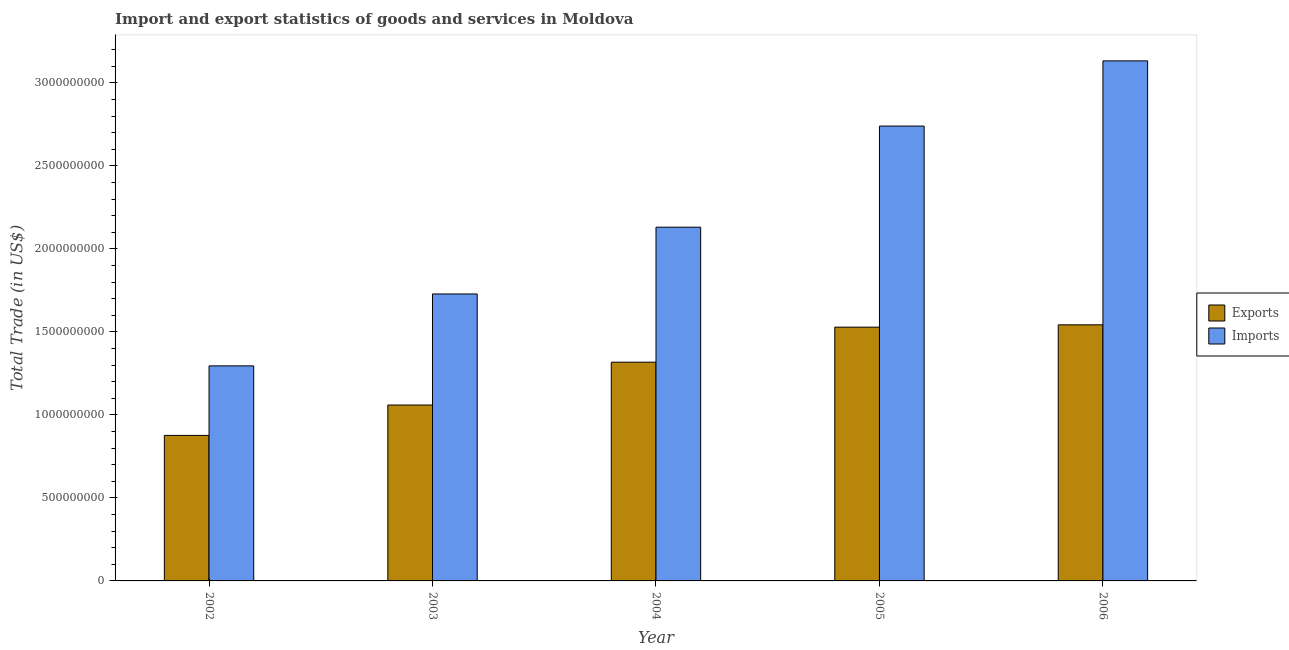How many groups of bars are there?
Your answer should be very brief. 5. How many bars are there on the 2nd tick from the left?
Offer a very short reply. 2. How many bars are there on the 3rd tick from the right?
Make the answer very short. 2. What is the label of the 5th group of bars from the left?
Give a very brief answer. 2006. In how many cases, is the number of bars for a given year not equal to the number of legend labels?
Offer a terse response. 0. What is the export of goods and services in 2005?
Offer a terse response. 1.53e+09. Across all years, what is the maximum imports of goods and services?
Provide a short and direct response. 3.13e+09. Across all years, what is the minimum imports of goods and services?
Provide a succinct answer. 1.30e+09. In which year was the export of goods and services maximum?
Your answer should be very brief. 2006. What is the total imports of goods and services in the graph?
Ensure brevity in your answer.  1.10e+1. What is the difference between the imports of goods and services in 2002 and that in 2003?
Provide a short and direct response. -4.33e+08. What is the difference between the imports of goods and services in 2005 and the export of goods and services in 2002?
Ensure brevity in your answer.  1.44e+09. What is the average export of goods and services per year?
Provide a succinct answer. 1.26e+09. In the year 2005, what is the difference between the export of goods and services and imports of goods and services?
Provide a short and direct response. 0. In how many years, is the imports of goods and services greater than 600000000 US$?
Offer a terse response. 5. What is the ratio of the imports of goods and services in 2004 to that in 2005?
Provide a short and direct response. 0.78. Is the difference between the export of goods and services in 2002 and 2006 greater than the difference between the imports of goods and services in 2002 and 2006?
Make the answer very short. No. What is the difference between the highest and the second highest imports of goods and services?
Ensure brevity in your answer.  3.93e+08. What is the difference between the highest and the lowest imports of goods and services?
Your response must be concise. 1.84e+09. In how many years, is the imports of goods and services greater than the average imports of goods and services taken over all years?
Provide a succinct answer. 2. What does the 2nd bar from the left in 2002 represents?
Ensure brevity in your answer.  Imports. What does the 1st bar from the right in 2002 represents?
Ensure brevity in your answer.  Imports. Are all the bars in the graph horizontal?
Make the answer very short. No. What is the difference between two consecutive major ticks on the Y-axis?
Provide a short and direct response. 5.00e+08. Are the values on the major ticks of Y-axis written in scientific E-notation?
Keep it short and to the point. No. Does the graph contain grids?
Provide a short and direct response. No. Where does the legend appear in the graph?
Your response must be concise. Center right. How are the legend labels stacked?
Offer a very short reply. Vertical. What is the title of the graph?
Your answer should be very brief. Import and export statistics of goods and services in Moldova. What is the label or title of the Y-axis?
Offer a very short reply. Total Trade (in US$). What is the Total Trade (in US$) of Exports in 2002?
Provide a succinct answer. 8.76e+08. What is the Total Trade (in US$) in Imports in 2002?
Your answer should be compact. 1.30e+09. What is the Total Trade (in US$) of Exports in 2003?
Offer a very short reply. 1.06e+09. What is the Total Trade (in US$) of Imports in 2003?
Provide a short and direct response. 1.73e+09. What is the Total Trade (in US$) of Exports in 2004?
Keep it short and to the point. 1.32e+09. What is the Total Trade (in US$) of Imports in 2004?
Provide a succinct answer. 2.13e+09. What is the Total Trade (in US$) in Exports in 2005?
Keep it short and to the point. 1.53e+09. What is the Total Trade (in US$) of Imports in 2005?
Ensure brevity in your answer.  2.74e+09. What is the Total Trade (in US$) of Exports in 2006?
Make the answer very short. 1.54e+09. What is the Total Trade (in US$) of Imports in 2006?
Your response must be concise. 3.13e+09. Across all years, what is the maximum Total Trade (in US$) in Exports?
Your answer should be compact. 1.54e+09. Across all years, what is the maximum Total Trade (in US$) of Imports?
Your response must be concise. 3.13e+09. Across all years, what is the minimum Total Trade (in US$) in Exports?
Provide a succinct answer. 8.76e+08. Across all years, what is the minimum Total Trade (in US$) of Imports?
Keep it short and to the point. 1.30e+09. What is the total Total Trade (in US$) of Exports in the graph?
Your answer should be compact. 6.32e+09. What is the total Total Trade (in US$) in Imports in the graph?
Offer a terse response. 1.10e+1. What is the difference between the Total Trade (in US$) in Exports in 2002 and that in 2003?
Your answer should be very brief. -1.83e+08. What is the difference between the Total Trade (in US$) in Imports in 2002 and that in 2003?
Provide a short and direct response. -4.33e+08. What is the difference between the Total Trade (in US$) in Exports in 2002 and that in 2004?
Make the answer very short. -4.41e+08. What is the difference between the Total Trade (in US$) of Imports in 2002 and that in 2004?
Provide a succinct answer. -8.35e+08. What is the difference between the Total Trade (in US$) of Exports in 2002 and that in 2005?
Give a very brief answer. -6.52e+08. What is the difference between the Total Trade (in US$) in Imports in 2002 and that in 2005?
Your answer should be very brief. -1.44e+09. What is the difference between the Total Trade (in US$) in Exports in 2002 and that in 2006?
Provide a succinct answer. -6.66e+08. What is the difference between the Total Trade (in US$) in Imports in 2002 and that in 2006?
Your response must be concise. -1.84e+09. What is the difference between the Total Trade (in US$) in Exports in 2003 and that in 2004?
Keep it short and to the point. -2.58e+08. What is the difference between the Total Trade (in US$) in Imports in 2003 and that in 2004?
Make the answer very short. -4.02e+08. What is the difference between the Total Trade (in US$) of Exports in 2003 and that in 2005?
Provide a succinct answer. -4.69e+08. What is the difference between the Total Trade (in US$) of Imports in 2003 and that in 2005?
Your answer should be compact. -1.01e+09. What is the difference between the Total Trade (in US$) in Exports in 2003 and that in 2006?
Your answer should be compact. -4.83e+08. What is the difference between the Total Trade (in US$) of Imports in 2003 and that in 2006?
Provide a succinct answer. -1.40e+09. What is the difference between the Total Trade (in US$) in Exports in 2004 and that in 2005?
Your answer should be very brief. -2.11e+08. What is the difference between the Total Trade (in US$) in Imports in 2004 and that in 2005?
Make the answer very short. -6.09e+08. What is the difference between the Total Trade (in US$) of Exports in 2004 and that in 2006?
Provide a short and direct response. -2.25e+08. What is the difference between the Total Trade (in US$) in Imports in 2004 and that in 2006?
Provide a succinct answer. -1.00e+09. What is the difference between the Total Trade (in US$) in Exports in 2005 and that in 2006?
Your answer should be compact. -1.41e+07. What is the difference between the Total Trade (in US$) of Imports in 2005 and that in 2006?
Make the answer very short. -3.93e+08. What is the difference between the Total Trade (in US$) in Exports in 2002 and the Total Trade (in US$) in Imports in 2003?
Your answer should be very brief. -8.52e+08. What is the difference between the Total Trade (in US$) in Exports in 2002 and the Total Trade (in US$) in Imports in 2004?
Provide a succinct answer. -1.25e+09. What is the difference between the Total Trade (in US$) of Exports in 2002 and the Total Trade (in US$) of Imports in 2005?
Provide a short and direct response. -1.86e+09. What is the difference between the Total Trade (in US$) in Exports in 2002 and the Total Trade (in US$) in Imports in 2006?
Provide a succinct answer. -2.26e+09. What is the difference between the Total Trade (in US$) of Exports in 2003 and the Total Trade (in US$) of Imports in 2004?
Provide a succinct answer. -1.07e+09. What is the difference between the Total Trade (in US$) in Exports in 2003 and the Total Trade (in US$) in Imports in 2005?
Give a very brief answer. -1.68e+09. What is the difference between the Total Trade (in US$) in Exports in 2003 and the Total Trade (in US$) in Imports in 2006?
Your answer should be very brief. -2.07e+09. What is the difference between the Total Trade (in US$) of Exports in 2004 and the Total Trade (in US$) of Imports in 2005?
Offer a very short reply. -1.42e+09. What is the difference between the Total Trade (in US$) in Exports in 2004 and the Total Trade (in US$) in Imports in 2006?
Offer a terse response. -1.81e+09. What is the difference between the Total Trade (in US$) of Exports in 2005 and the Total Trade (in US$) of Imports in 2006?
Offer a terse response. -1.60e+09. What is the average Total Trade (in US$) of Exports per year?
Your response must be concise. 1.26e+09. What is the average Total Trade (in US$) in Imports per year?
Your answer should be compact. 2.21e+09. In the year 2002, what is the difference between the Total Trade (in US$) in Exports and Total Trade (in US$) in Imports?
Your answer should be compact. -4.19e+08. In the year 2003, what is the difference between the Total Trade (in US$) in Exports and Total Trade (in US$) in Imports?
Make the answer very short. -6.69e+08. In the year 2004, what is the difference between the Total Trade (in US$) of Exports and Total Trade (in US$) of Imports?
Keep it short and to the point. -8.13e+08. In the year 2005, what is the difference between the Total Trade (in US$) of Exports and Total Trade (in US$) of Imports?
Give a very brief answer. -1.21e+09. In the year 2006, what is the difference between the Total Trade (in US$) of Exports and Total Trade (in US$) of Imports?
Provide a short and direct response. -1.59e+09. What is the ratio of the Total Trade (in US$) of Exports in 2002 to that in 2003?
Offer a very short reply. 0.83. What is the ratio of the Total Trade (in US$) of Imports in 2002 to that in 2003?
Offer a terse response. 0.75. What is the ratio of the Total Trade (in US$) in Exports in 2002 to that in 2004?
Give a very brief answer. 0.67. What is the ratio of the Total Trade (in US$) in Imports in 2002 to that in 2004?
Provide a succinct answer. 0.61. What is the ratio of the Total Trade (in US$) in Exports in 2002 to that in 2005?
Make the answer very short. 0.57. What is the ratio of the Total Trade (in US$) of Imports in 2002 to that in 2005?
Make the answer very short. 0.47. What is the ratio of the Total Trade (in US$) in Exports in 2002 to that in 2006?
Provide a short and direct response. 0.57. What is the ratio of the Total Trade (in US$) in Imports in 2002 to that in 2006?
Provide a short and direct response. 0.41. What is the ratio of the Total Trade (in US$) in Exports in 2003 to that in 2004?
Offer a terse response. 0.8. What is the ratio of the Total Trade (in US$) of Imports in 2003 to that in 2004?
Your answer should be compact. 0.81. What is the ratio of the Total Trade (in US$) of Exports in 2003 to that in 2005?
Offer a very short reply. 0.69. What is the ratio of the Total Trade (in US$) in Imports in 2003 to that in 2005?
Make the answer very short. 0.63. What is the ratio of the Total Trade (in US$) in Exports in 2003 to that in 2006?
Offer a terse response. 0.69. What is the ratio of the Total Trade (in US$) in Imports in 2003 to that in 2006?
Offer a terse response. 0.55. What is the ratio of the Total Trade (in US$) in Exports in 2004 to that in 2005?
Offer a terse response. 0.86. What is the ratio of the Total Trade (in US$) of Imports in 2004 to that in 2005?
Offer a terse response. 0.78. What is the ratio of the Total Trade (in US$) of Exports in 2004 to that in 2006?
Offer a terse response. 0.85. What is the ratio of the Total Trade (in US$) in Imports in 2004 to that in 2006?
Offer a terse response. 0.68. What is the ratio of the Total Trade (in US$) of Exports in 2005 to that in 2006?
Provide a short and direct response. 0.99. What is the ratio of the Total Trade (in US$) in Imports in 2005 to that in 2006?
Your answer should be compact. 0.87. What is the difference between the highest and the second highest Total Trade (in US$) of Exports?
Provide a short and direct response. 1.41e+07. What is the difference between the highest and the second highest Total Trade (in US$) in Imports?
Provide a short and direct response. 3.93e+08. What is the difference between the highest and the lowest Total Trade (in US$) of Exports?
Ensure brevity in your answer.  6.66e+08. What is the difference between the highest and the lowest Total Trade (in US$) in Imports?
Your response must be concise. 1.84e+09. 